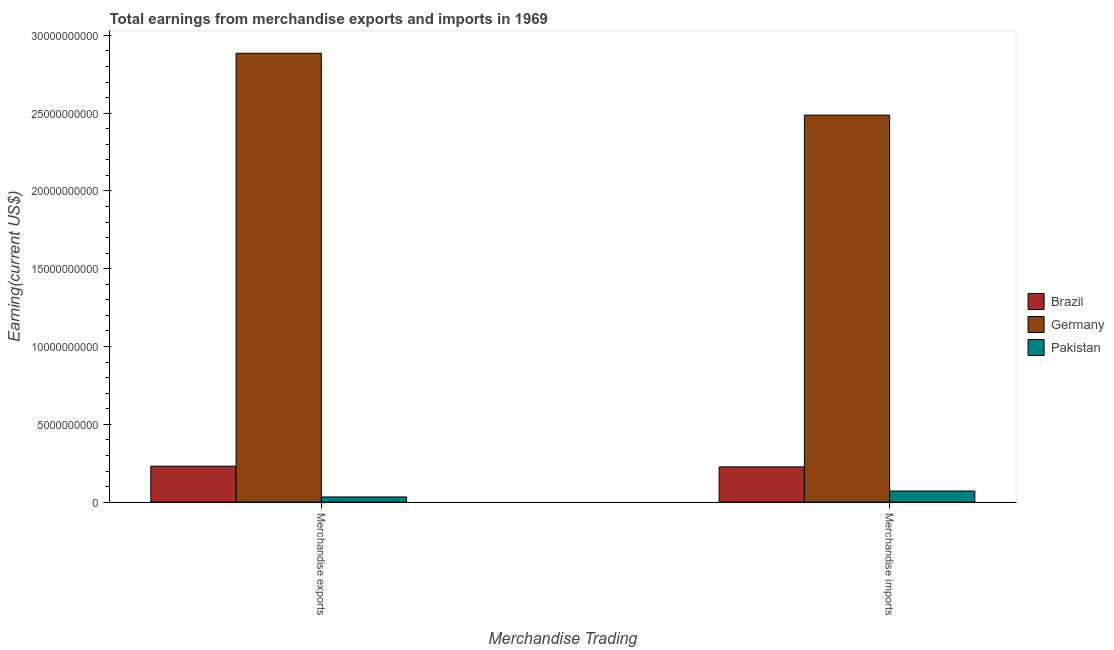Are the number of bars on each tick of the X-axis equal?
Keep it short and to the point. Yes. What is the earnings from merchandise exports in Brazil?
Offer a terse response. 2.31e+09. Across all countries, what is the maximum earnings from merchandise imports?
Your answer should be compact. 2.49e+1. Across all countries, what is the minimum earnings from merchandise exports?
Your answer should be compact. 3.32e+08. In which country was the earnings from merchandise imports minimum?
Keep it short and to the point. Pakistan. What is the total earnings from merchandise imports in the graph?
Your answer should be compact. 2.79e+1. What is the difference between the earnings from merchandise imports in Germany and that in Pakistan?
Your response must be concise. 2.42e+1. What is the difference between the earnings from merchandise exports in Pakistan and the earnings from merchandise imports in Germany?
Your answer should be compact. -2.45e+1. What is the average earnings from merchandise exports per country?
Ensure brevity in your answer.  1.05e+1. What is the difference between the earnings from merchandise imports and earnings from merchandise exports in Germany?
Make the answer very short. -3.98e+09. In how many countries, is the earnings from merchandise imports greater than 12000000000 US$?
Provide a short and direct response. 1. What is the ratio of the earnings from merchandise imports in Pakistan to that in Brazil?
Offer a terse response. 0.31. In how many countries, is the earnings from merchandise imports greater than the average earnings from merchandise imports taken over all countries?
Provide a short and direct response. 1. What does the 1st bar from the left in Merchandise exports represents?
Ensure brevity in your answer.  Brazil. What does the 1st bar from the right in Merchandise imports represents?
Provide a short and direct response. Pakistan. How many bars are there?
Your answer should be compact. 6. How many countries are there in the graph?
Offer a very short reply. 3. Does the graph contain grids?
Ensure brevity in your answer.  No. How are the legend labels stacked?
Give a very brief answer. Vertical. What is the title of the graph?
Offer a very short reply. Total earnings from merchandise exports and imports in 1969. What is the label or title of the X-axis?
Provide a short and direct response. Merchandise Trading. What is the label or title of the Y-axis?
Provide a succinct answer. Earning(current US$). What is the Earning(current US$) of Brazil in Merchandise exports?
Your response must be concise. 2.31e+09. What is the Earning(current US$) in Germany in Merchandise exports?
Provide a short and direct response. 2.89e+1. What is the Earning(current US$) of Pakistan in Merchandise exports?
Ensure brevity in your answer.  3.32e+08. What is the Earning(current US$) in Brazil in Merchandise imports?
Offer a terse response. 2.26e+09. What is the Earning(current US$) in Germany in Merchandise imports?
Your answer should be very brief. 2.49e+1. What is the Earning(current US$) in Pakistan in Merchandise imports?
Give a very brief answer. 7.13e+08. Across all Merchandise Trading, what is the maximum Earning(current US$) of Brazil?
Your answer should be very brief. 2.31e+09. Across all Merchandise Trading, what is the maximum Earning(current US$) of Germany?
Give a very brief answer. 2.89e+1. Across all Merchandise Trading, what is the maximum Earning(current US$) of Pakistan?
Your response must be concise. 7.13e+08. Across all Merchandise Trading, what is the minimum Earning(current US$) in Brazil?
Your answer should be compact. 2.26e+09. Across all Merchandise Trading, what is the minimum Earning(current US$) of Germany?
Offer a very short reply. 2.49e+1. Across all Merchandise Trading, what is the minimum Earning(current US$) of Pakistan?
Make the answer very short. 3.32e+08. What is the total Earning(current US$) in Brazil in the graph?
Give a very brief answer. 4.58e+09. What is the total Earning(current US$) in Germany in the graph?
Ensure brevity in your answer.  5.37e+1. What is the total Earning(current US$) in Pakistan in the graph?
Offer a very short reply. 1.04e+09. What is the difference between the Earning(current US$) of Brazil in Merchandise exports and that in Merchandise imports?
Offer a terse response. 4.60e+07. What is the difference between the Earning(current US$) of Germany in Merchandise exports and that in Merchandise imports?
Keep it short and to the point. 3.98e+09. What is the difference between the Earning(current US$) of Pakistan in Merchandise exports and that in Merchandise imports?
Your response must be concise. -3.82e+08. What is the difference between the Earning(current US$) of Brazil in Merchandise exports and the Earning(current US$) of Germany in Merchandise imports?
Give a very brief answer. -2.26e+1. What is the difference between the Earning(current US$) of Brazil in Merchandise exports and the Earning(current US$) of Pakistan in Merchandise imports?
Provide a short and direct response. 1.60e+09. What is the difference between the Earning(current US$) in Germany in Merchandise exports and the Earning(current US$) in Pakistan in Merchandise imports?
Your response must be concise. 2.81e+1. What is the average Earning(current US$) of Brazil per Merchandise Trading?
Ensure brevity in your answer.  2.29e+09. What is the average Earning(current US$) of Germany per Merchandise Trading?
Offer a very short reply. 2.69e+1. What is the average Earning(current US$) in Pakistan per Merchandise Trading?
Give a very brief answer. 5.22e+08. What is the difference between the Earning(current US$) of Brazil and Earning(current US$) of Germany in Merchandise exports?
Provide a short and direct response. -2.65e+1. What is the difference between the Earning(current US$) in Brazil and Earning(current US$) in Pakistan in Merchandise exports?
Keep it short and to the point. 1.98e+09. What is the difference between the Earning(current US$) in Germany and Earning(current US$) in Pakistan in Merchandise exports?
Make the answer very short. 2.85e+1. What is the difference between the Earning(current US$) of Brazil and Earning(current US$) of Germany in Merchandise imports?
Give a very brief answer. -2.26e+1. What is the difference between the Earning(current US$) in Brazil and Earning(current US$) in Pakistan in Merchandise imports?
Provide a short and direct response. 1.55e+09. What is the difference between the Earning(current US$) of Germany and Earning(current US$) of Pakistan in Merchandise imports?
Offer a terse response. 2.42e+1. What is the ratio of the Earning(current US$) in Brazil in Merchandise exports to that in Merchandise imports?
Give a very brief answer. 1.02. What is the ratio of the Earning(current US$) in Germany in Merchandise exports to that in Merchandise imports?
Offer a terse response. 1.16. What is the ratio of the Earning(current US$) in Pakistan in Merchandise exports to that in Merchandise imports?
Ensure brevity in your answer.  0.46. What is the difference between the highest and the second highest Earning(current US$) in Brazil?
Provide a short and direct response. 4.60e+07. What is the difference between the highest and the second highest Earning(current US$) of Germany?
Keep it short and to the point. 3.98e+09. What is the difference between the highest and the second highest Earning(current US$) in Pakistan?
Your answer should be very brief. 3.82e+08. What is the difference between the highest and the lowest Earning(current US$) in Brazil?
Your answer should be compact. 4.60e+07. What is the difference between the highest and the lowest Earning(current US$) in Germany?
Offer a very short reply. 3.98e+09. What is the difference between the highest and the lowest Earning(current US$) of Pakistan?
Your response must be concise. 3.82e+08. 